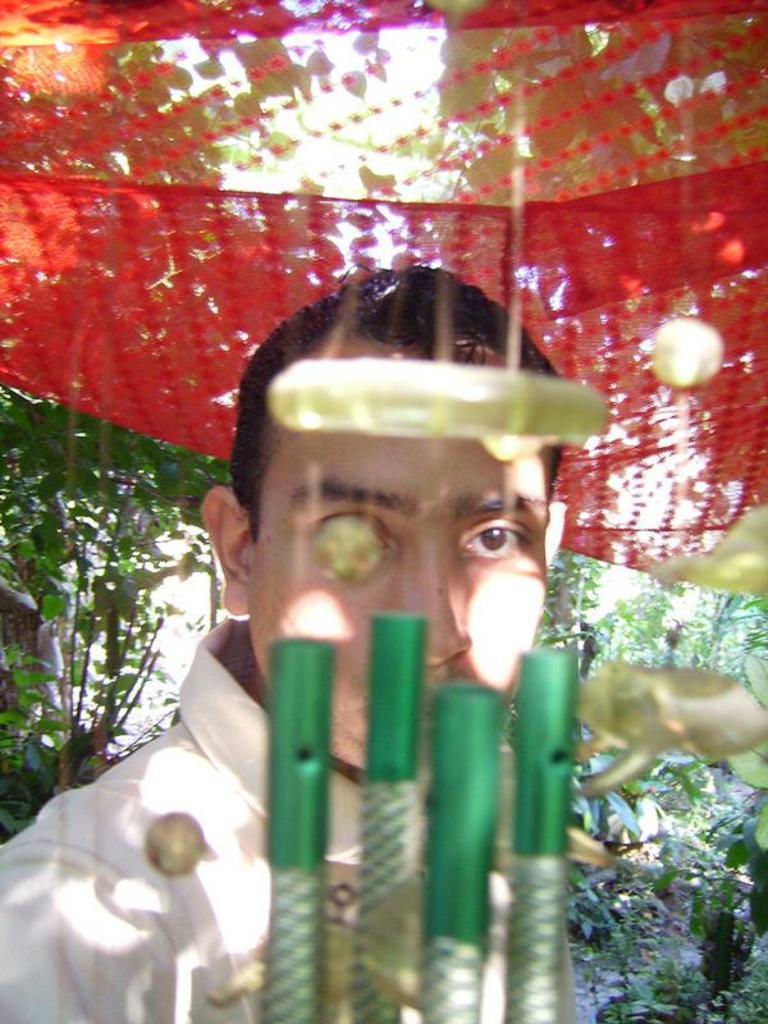Can you describe this image briefly? In this image there is a person staring at wind Chimes, behind the person there are trees. 